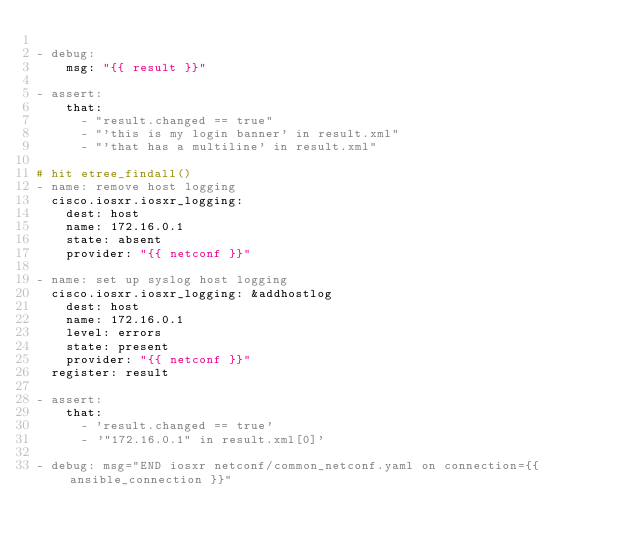Convert code to text. <code><loc_0><loc_0><loc_500><loc_500><_YAML_>
- debug:
    msg: "{{ result }}"

- assert:
    that:
      - "result.changed == true"
      - "'this is my login banner' in result.xml"
      - "'that has a multiline' in result.xml"

# hit etree_findall()
- name: remove host logging
  cisco.iosxr.iosxr_logging:
    dest: host
    name: 172.16.0.1
    state: absent
    provider: "{{ netconf }}"

- name: set up syslog host logging
  cisco.iosxr.iosxr_logging: &addhostlog
    dest: host
    name: 172.16.0.1
    level: errors
    state: present
    provider: "{{ netconf }}"
  register: result

- assert:
    that:
      - 'result.changed == true'
      - '"172.16.0.1" in result.xml[0]'

- debug: msg="END iosxr netconf/common_netconf.yaml on connection={{ ansible_connection }}"
</code> 